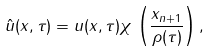<formula> <loc_0><loc_0><loc_500><loc_500>\hat { u } ( x , \tau ) = u ( x , \tau ) \chi \, \left ( \frac { x _ { n + 1 } } { \rho ( \tau ) } \right ) ,</formula> 